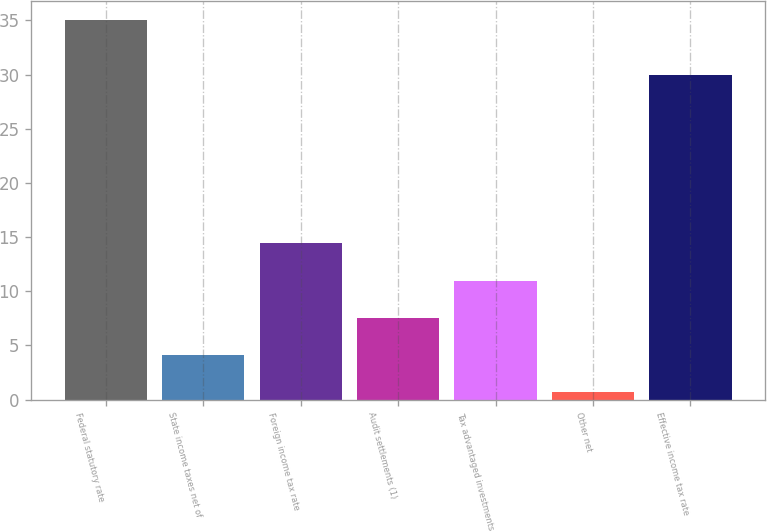Convert chart to OTSL. <chart><loc_0><loc_0><loc_500><loc_500><bar_chart><fcel>Federal statutory rate<fcel>State income taxes net of<fcel>Foreign income tax rate<fcel>Audit settlements (1)<fcel>Tax advantaged investments<fcel>Other net<fcel>Effective income tax rate<nl><fcel>35<fcel>4.13<fcel>14.42<fcel>7.56<fcel>10.99<fcel>0.7<fcel>30<nl></chart> 